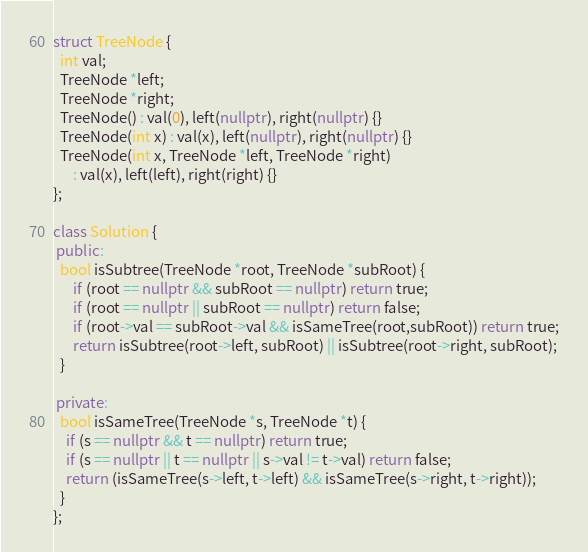<code> <loc_0><loc_0><loc_500><loc_500><_C++_>
struct TreeNode {
  int val;
  TreeNode *left;
  TreeNode *right;
  TreeNode() : val(0), left(nullptr), right(nullptr) {}
  TreeNode(int x) : val(x), left(nullptr), right(nullptr) {}
  TreeNode(int x, TreeNode *left, TreeNode *right)
      : val(x), left(left), right(right) {}
};

class Solution {
 public:
  bool isSubtree(TreeNode *root, TreeNode *subRoot) {
      if (root == nullptr && subRoot == nullptr) return true;
      if (root == nullptr || subRoot == nullptr) return false;
      if (root->val == subRoot->val && isSameTree(root,subRoot)) return true;
      return isSubtree(root->left, subRoot) || isSubtree(root->right, subRoot);
  }

 private:
  bool isSameTree(TreeNode *s, TreeNode *t) {
    if (s == nullptr && t == nullptr) return true;
    if (s == nullptr || t == nullptr || s->val != t->val) return false;
    return (isSameTree(s->left, t->left) && isSameTree(s->right, t->right));
  }
};</code> 